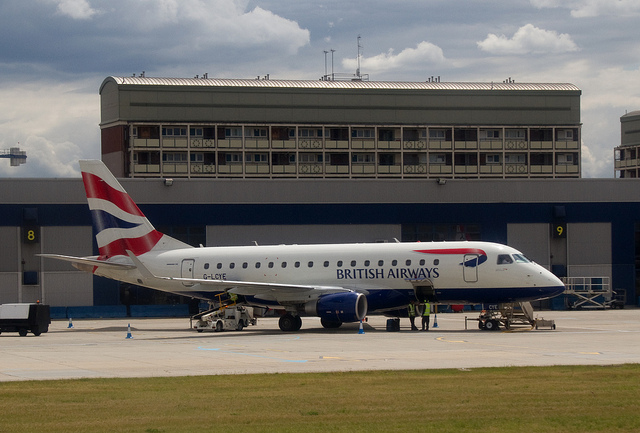Extract all visible text content from this image. AIRWAYS BRITISH 8 9 